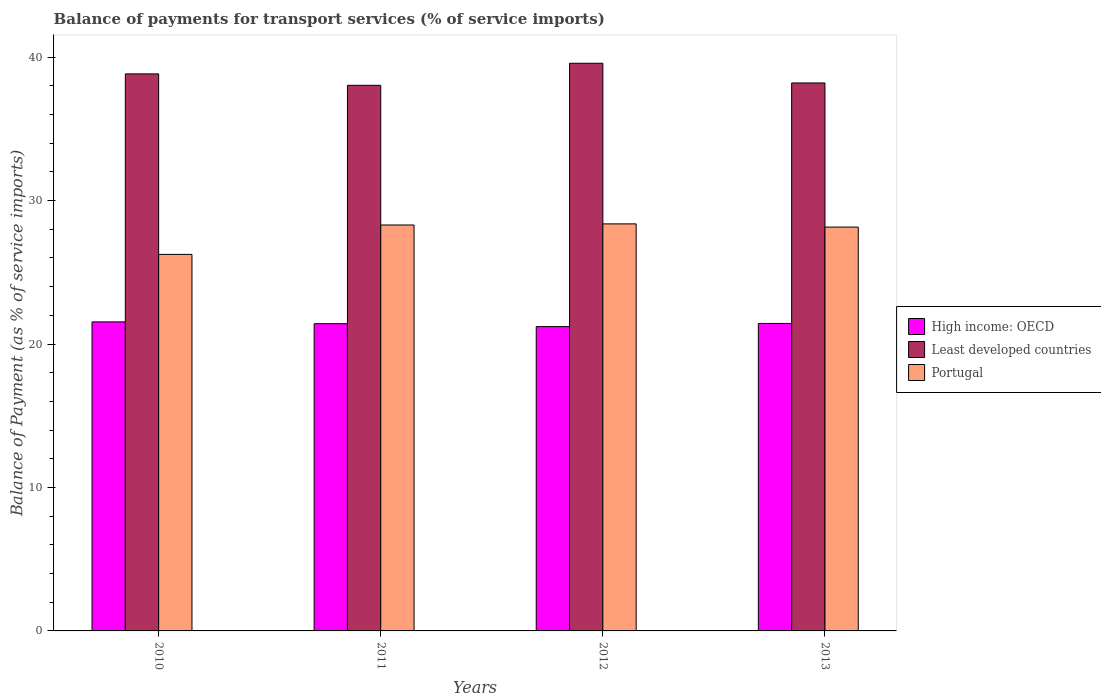How many groups of bars are there?
Keep it short and to the point. 4. Are the number of bars per tick equal to the number of legend labels?
Your answer should be very brief. Yes. Are the number of bars on each tick of the X-axis equal?
Your answer should be compact. Yes. How many bars are there on the 3rd tick from the left?
Provide a succinct answer. 3. How many bars are there on the 2nd tick from the right?
Keep it short and to the point. 3. What is the label of the 2nd group of bars from the left?
Your answer should be compact. 2011. What is the balance of payments for transport services in Least developed countries in 2011?
Give a very brief answer. 38.03. Across all years, what is the maximum balance of payments for transport services in Least developed countries?
Offer a terse response. 39.57. Across all years, what is the minimum balance of payments for transport services in High income: OECD?
Provide a short and direct response. 21.21. In which year was the balance of payments for transport services in Least developed countries maximum?
Keep it short and to the point. 2012. In which year was the balance of payments for transport services in High income: OECD minimum?
Provide a short and direct response. 2012. What is the total balance of payments for transport services in Least developed countries in the graph?
Make the answer very short. 154.63. What is the difference between the balance of payments for transport services in High income: OECD in 2011 and that in 2013?
Your response must be concise. -0.02. What is the difference between the balance of payments for transport services in Least developed countries in 2011 and the balance of payments for transport services in High income: OECD in 2010?
Your answer should be compact. 16.49. What is the average balance of payments for transport services in High income: OECD per year?
Provide a short and direct response. 21.4. In the year 2011, what is the difference between the balance of payments for transport services in Portugal and balance of payments for transport services in Least developed countries?
Give a very brief answer. -9.74. What is the ratio of the balance of payments for transport services in Portugal in 2011 to that in 2012?
Your response must be concise. 1. Is the balance of payments for transport services in Portugal in 2010 less than that in 2012?
Make the answer very short. Yes. Is the difference between the balance of payments for transport services in Portugal in 2012 and 2013 greater than the difference between the balance of payments for transport services in Least developed countries in 2012 and 2013?
Your answer should be very brief. No. What is the difference between the highest and the second highest balance of payments for transport services in High income: OECD?
Give a very brief answer. 0.11. What is the difference between the highest and the lowest balance of payments for transport services in Portugal?
Your response must be concise. 2.13. In how many years, is the balance of payments for transport services in Least developed countries greater than the average balance of payments for transport services in Least developed countries taken over all years?
Ensure brevity in your answer.  2. What does the 1st bar from the left in 2011 represents?
Offer a terse response. High income: OECD. Is it the case that in every year, the sum of the balance of payments for transport services in High income: OECD and balance of payments for transport services in Portugal is greater than the balance of payments for transport services in Least developed countries?
Keep it short and to the point. Yes. How many bars are there?
Provide a short and direct response. 12. What is the difference between two consecutive major ticks on the Y-axis?
Your answer should be compact. 10. Are the values on the major ticks of Y-axis written in scientific E-notation?
Your response must be concise. No. Does the graph contain grids?
Offer a terse response. No. Where does the legend appear in the graph?
Your answer should be compact. Center right. How many legend labels are there?
Make the answer very short. 3. What is the title of the graph?
Offer a very short reply. Balance of payments for transport services (% of service imports). What is the label or title of the Y-axis?
Provide a short and direct response. Balance of Payment (as % of service imports). What is the Balance of Payment (as % of service imports) of High income: OECD in 2010?
Your answer should be very brief. 21.54. What is the Balance of Payment (as % of service imports) of Least developed countries in 2010?
Your response must be concise. 38.83. What is the Balance of Payment (as % of service imports) of Portugal in 2010?
Keep it short and to the point. 26.25. What is the Balance of Payment (as % of service imports) in High income: OECD in 2011?
Your answer should be compact. 21.42. What is the Balance of Payment (as % of service imports) of Least developed countries in 2011?
Offer a very short reply. 38.03. What is the Balance of Payment (as % of service imports) in Portugal in 2011?
Your answer should be very brief. 28.3. What is the Balance of Payment (as % of service imports) of High income: OECD in 2012?
Your response must be concise. 21.21. What is the Balance of Payment (as % of service imports) of Least developed countries in 2012?
Provide a succinct answer. 39.57. What is the Balance of Payment (as % of service imports) in Portugal in 2012?
Your answer should be compact. 28.37. What is the Balance of Payment (as % of service imports) of High income: OECD in 2013?
Give a very brief answer. 21.43. What is the Balance of Payment (as % of service imports) in Least developed countries in 2013?
Provide a succinct answer. 38.2. What is the Balance of Payment (as % of service imports) of Portugal in 2013?
Provide a short and direct response. 28.15. Across all years, what is the maximum Balance of Payment (as % of service imports) of High income: OECD?
Make the answer very short. 21.54. Across all years, what is the maximum Balance of Payment (as % of service imports) in Least developed countries?
Your answer should be very brief. 39.57. Across all years, what is the maximum Balance of Payment (as % of service imports) of Portugal?
Your response must be concise. 28.37. Across all years, what is the minimum Balance of Payment (as % of service imports) of High income: OECD?
Provide a succinct answer. 21.21. Across all years, what is the minimum Balance of Payment (as % of service imports) in Least developed countries?
Provide a succinct answer. 38.03. Across all years, what is the minimum Balance of Payment (as % of service imports) of Portugal?
Your answer should be very brief. 26.25. What is the total Balance of Payment (as % of service imports) in High income: OECD in the graph?
Ensure brevity in your answer.  85.61. What is the total Balance of Payment (as % of service imports) in Least developed countries in the graph?
Offer a terse response. 154.63. What is the total Balance of Payment (as % of service imports) of Portugal in the graph?
Give a very brief answer. 111.07. What is the difference between the Balance of Payment (as % of service imports) of High income: OECD in 2010 and that in 2011?
Your answer should be compact. 0.13. What is the difference between the Balance of Payment (as % of service imports) in Least developed countries in 2010 and that in 2011?
Your answer should be compact. 0.8. What is the difference between the Balance of Payment (as % of service imports) in Portugal in 2010 and that in 2011?
Give a very brief answer. -2.05. What is the difference between the Balance of Payment (as % of service imports) in High income: OECD in 2010 and that in 2012?
Your answer should be very brief. 0.33. What is the difference between the Balance of Payment (as % of service imports) of Least developed countries in 2010 and that in 2012?
Give a very brief answer. -0.74. What is the difference between the Balance of Payment (as % of service imports) of Portugal in 2010 and that in 2012?
Offer a terse response. -2.13. What is the difference between the Balance of Payment (as % of service imports) in High income: OECD in 2010 and that in 2013?
Your response must be concise. 0.11. What is the difference between the Balance of Payment (as % of service imports) of Least developed countries in 2010 and that in 2013?
Keep it short and to the point. 0.63. What is the difference between the Balance of Payment (as % of service imports) of Portugal in 2010 and that in 2013?
Make the answer very short. -1.91. What is the difference between the Balance of Payment (as % of service imports) in High income: OECD in 2011 and that in 2012?
Your answer should be compact. 0.2. What is the difference between the Balance of Payment (as % of service imports) in Least developed countries in 2011 and that in 2012?
Make the answer very short. -1.54. What is the difference between the Balance of Payment (as % of service imports) of Portugal in 2011 and that in 2012?
Your answer should be compact. -0.08. What is the difference between the Balance of Payment (as % of service imports) of High income: OECD in 2011 and that in 2013?
Ensure brevity in your answer.  -0.02. What is the difference between the Balance of Payment (as % of service imports) of Least developed countries in 2011 and that in 2013?
Offer a very short reply. -0.16. What is the difference between the Balance of Payment (as % of service imports) in Portugal in 2011 and that in 2013?
Provide a short and direct response. 0.14. What is the difference between the Balance of Payment (as % of service imports) in High income: OECD in 2012 and that in 2013?
Your answer should be very brief. -0.22. What is the difference between the Balance of Payment (as % of service imports) in Least developed countries in 2012 and that in 2013?
Make the answer very short. 1.37. What is the difference between the Balance of Payment (as % of service imports) in Portugal in 2012 and that in 2013?
Keep it short and to the point. 0.22. What is the difference between the Balance of Payment (as % of service imports) of High income: OECD in 2010 and the Balance of Payment (as % of service imports) of Least developed countries in 2011?
Your response must be concise. -16.49. What is the difference between the Balance of Payment (as % of service imports) in High income: OECD in 2010 and the Balance of Payment (as % of service imports) in Portugal in 2011?
Offer a terse response. -6.75. What is the difference between the Balance of Payment (as % of service imports) of Least developed countries in 2010 and the Balance of Payment (as % of service imports) of Portugal in 2011?
Your response must be concise. 10.53. What is the difference between the Balance of Payment (as % of service imports) of High income: OECD in 2010 and the Balance of Payment (as % of service imports) of Least developed countries in 2012?
Provide a short and direct response. -18.03. What is the difference between the Balance of Payment (as % of service imports) of High income: OECD in 2010 and the Balance of Payment (as % of service imports) of Portugal in 2012?
Your answer should be very brief. -6.83. What is the difference between the Balance of Payment (as % of service imports) in Least developed countries in 2010 and the Balance of Payment (as % of service imports) in Portugal in 2012?
Make the answer very short. 10.46. What is the difference between the Balance of Payment (as % of service imports) in High income: OECD in 2010 and the Balance of Payment (as % of service imports) in Least developed countries in 2013?
Your response must be concise. -16.66. What is the difference between the Balance of Payment (as % of service imports) in High income: OECD in 2010 and the Balance of Payment (as % of service imports) in Portugal in 2013?
Offer a terse response. -6.61. What is the difference between the Balance of Payment (as % of service imports) of Least developed countries in 2010 and the Balance of Payment (as % of service imports) of Portugal in 2013?
Provide a short and direct response. 10.68. What is the difference between the Balance of Payment (as % of service imports) of High income: OECD in 2011 and the Balance of Payment (as % of service imports) of Least developed countries in 2012?
Offer a very short reply. -18.15. What is the difference between the Balance of Payment (as % of service imports) in High income: OECD in 2011 and the Balance of Payment (as % of service imports) in Portugal in 2012?
Your answer should be very brief. -6.96. What is the difference between the Balance of Payment (as % of service imports) in Least developed countries in 2011 and the Balance of Payment (as % of service imports) in Portugal in 2012?
Provide a succinct answer. 9.66. What is the difference between the Balance of Payment (as % of service imports) in High income: OECD in 2011 and the Balance of Payment (as % of service imports) in Least developed countries in 2013?
Ensure brevity in your answer.  -16.78. What is the difference between the Balance of Payment (as % of service imports) in High income: OECD in 2011 and the Balance of Payment (as % of service imports) in Portugal in 2013?
Make the answer very short. -6.74. What is the difference between the Balance of Payment (as % of service imports) of Least developed countries in 2011 and the Balance of Payment (as % of service imports) of Portugal in 2013?
Provide a short and direct response. 9.88. What is the difference between the Balance of Payment (as % of service imports) in High income: OECD in 2012 and the Balance of Payment (as % of service imports) in Least developed countries in 2013?
Provide a succinct answer. -16.98. What is the difference between the Balance of Payment (as % of service imports) in High income: OECD in 2012 and the Balance of Payment (as % of service imports) in Portugal in 2013?
Offer a very short reply. -6.94. What is the difference between the Balance of Payment (as % of service imports) in Least developed countries in 2012 and the Balance of Payment (as % of service imports) in Portugal in 2013?
Keep it short and to the point. 11.42. What is the average Balance of Payment (as % of service imports) in High income: OECD per year?
Give a very brief answer. 21.4. What is the average Balance of Payment (as % of service imports) of Least developed countries per year?
Your answer should be very brief. 38.66. What is the average Balance of Payment (as % of service imports) in Portugal per year?
Your answer should be compact. 27.77. In the year 2010, what is the difference between the Balance of Payment (as % of service imports) in High income: OECD and Balance of Payment (as % of service imports) in Least developed countries?
Provide a short and direct response. -17.29. In the year 2010, what is the difference between the Balance of Payment (as % of service imports) of High income: OECD and Balance of Payment (as % of service imports) of Portugal?
Make the answer very short. -4.71. In the year 2010, what is the difference between the Balance of Payment (as % of service imports) of Least developed countries and Balance of Payment (as % of service imports) of Portugal?
Make the answer very short. 12.58. In the year 2011, what is the difference between the Balance of Payment (as % of service imports) of High income: OECD and Balance of Payment (as % of service imports) of Least developed countries?
Make the answer very short. -16.62. In the year 2011, what is the difference between the Balance of Payment (as % of service imports) of High income: OECD and Balance of Payment (as % of service imports) of Portugal?
Provide a succinct answer. -6.88. In the year 2011, what is the difference between the Balance of Payment (as % of service imports) of Least developed countries and Balance of Payment (as % of service imports) of Portugal?
Your response must be concise. 9.74. In the year 2012, what is the difference between the Balance of Payment (as % of service imports) of High income: OECD and Balance of Payment (as % of service imports) of Least developed countries?
Offer a very short reply. -18.36. In the year 2012, what is the difference between the Balance of Payment (as % of service imports) of High income: OECD and Balance of Payment (as % of service imports) of Portugal?
Your response must be concise. -7.16. In the year 2012, what is the difference between the Balance of Payment (as % of service imports) of Least developed countries and Balance of Payment (as % of service imports) of Portugal?
Give a very brief answer. 11.2. In the year 2013, what is the difference between the Balance of Payment (as % of service imports) of High income: OECD and Balance of Payment (as % of service imports) of Least developed countries?
Provide a succinct answer. -16.76. In the year 2013, what is the difference between the Balance of Payment (as % of service imports) in High income: OECD and Balance of Payment (as % of service imports) in Portugal?
Your response must be concise. -6.72. In the year 2013, what is the difference between the Balance of Payment (as % of service imports) in Least developed countries and Balance of Payment (as % of service imports) in Portugal?
Offer a terse response. 10.04. What is the ratio of the Balance of Payment (as % of service imports) of Least developed countries in 2010 to that in 2011?
Your answer should be very brief. 1.02. What is the ratio of the Balance of Payment (as % of service imports) in Portugal in 2010 to that in 2011?
Your response must be concise. 0.93. What is the ratio of the Balance of Payment (as % of service imports) of High income: OECD in 2010 to that in 2012?
Provide a short and direct response. 1.02. What is the ratio of the Balance of Payment (as % of service imports) in Least developed countries in 2010 to that in 2012?
Your answer should be very brief. 0.98. What is the ratio of the Balance of Payment (as % of service imports) of Portugal in 2010 to that in 2012?
Ensure brevity in your answer.  0.93. What is the ratio of the Balance of Payment (as % of service imports) in Least developed countries in 2010 to that in 2013?
Your answer should be very brief. 1.02. What is the ratio of the Balance of Payment (as % of service imports) of Portugal in 2010 to that in 2013?
Make the answer very short. 0.93. What is the ratio of the Balance of Payment (as % of service imports) in High income: OECD in 2011 to that in 2012?
Your answer should be compact. 1.01. What is the ratio of the Balance of Payment (as % of service imports) of Least developed countries in 2011 to that in 2012?
Keep it short and to the point. 0.96. What is the ratio of the Balance of Payment (as % of service imports) in High income: OECD in 2011 to that in 2013?
Your answer should be very brief. 1. What is the ratio of the Balance of Payment (as % of service imports) in Portugal in 2011 to that in 2013?
Offer a very short reply. 1.01. What is the ratio of the Balance of Payment (as % of service imports) in Least developed countries in 2012 to that in 2013?
Your response must be concise. 1.04. What is the ratio of the Balance of Payment (as % of service imports) of Portugal in 2012 to that in 2013?
Provide a succinct answer. 1.01. What is the difference between the highest and the second highest Balance of Payment (as % of service imports) in High income: OECD?
Provide a short and direct response. 0.11. What is the difference between the highest and the second highest Balance of Payment (as % of service imports) in Least developed countries?
Offer a very short reply. 0.74. What is the difference between the highest and the second highest Balance of Payment (as % of service imports) in Portugal?
Offer a very short reply. 0.08. What is the difference between the highest and the lowest Balance of Payment (as % of service imports) in High income: OECD?
Your answer should be very brief. 0.33. What is the difference between the highest and the lowest Balance of Payment (as % of service imports) of Least developed countries?
Provide a short and direct response. 1.54. What is the difference between the highest and the lowest Balance of Payment (as % of service imports) of Portugal?
Ensure brevity in your answer.  2.13. 